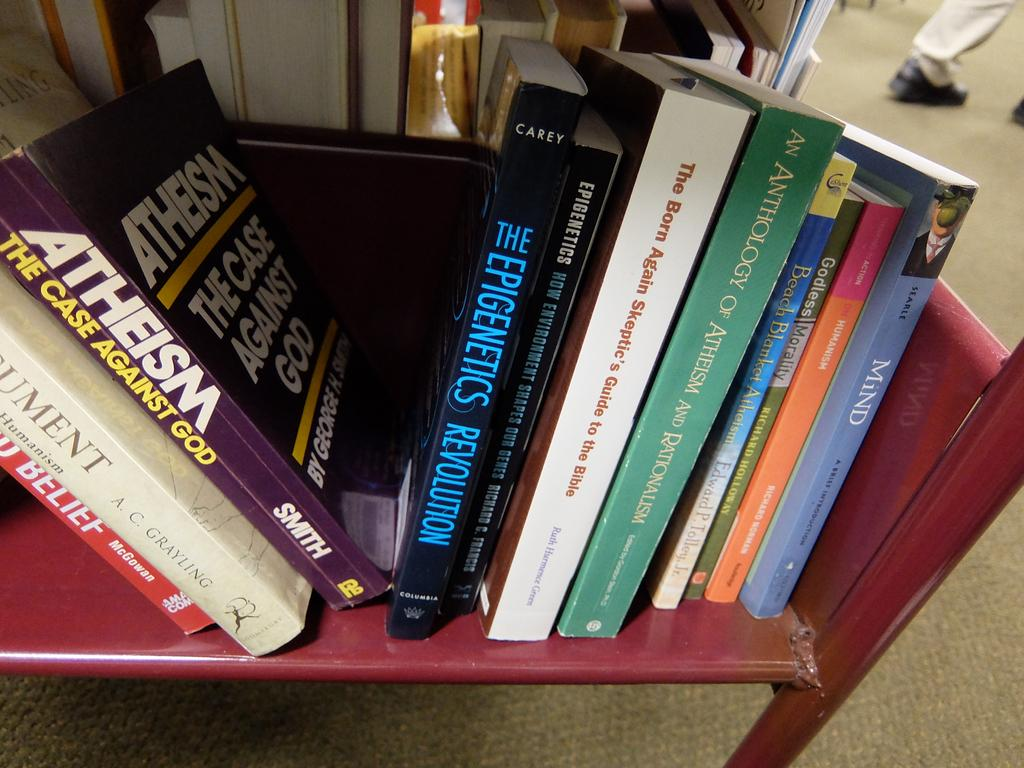<image>
Describe the image concisely. A group of books about athiesm sit on a red shelf. 